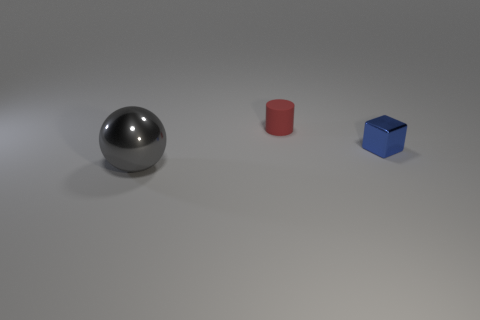Add 2 small metal objects. How many objects exist? 5 Add 2 small gray metallic cylinders. How many small gray metallic cylinders exist? 2 Subtract 0 gray cylinders. How many objects are left? 3 Subtract all cylinders. How many objects are left? 2 Subtract all cyan balls. Subtract all brown cylinders. How many balls are left? 1 Subtract all tiny gray matte cylinders. Subtract all blue blocks. How many objects are left? 2 Add 1 matte cylinders. How many matte cylinders are left? 2 